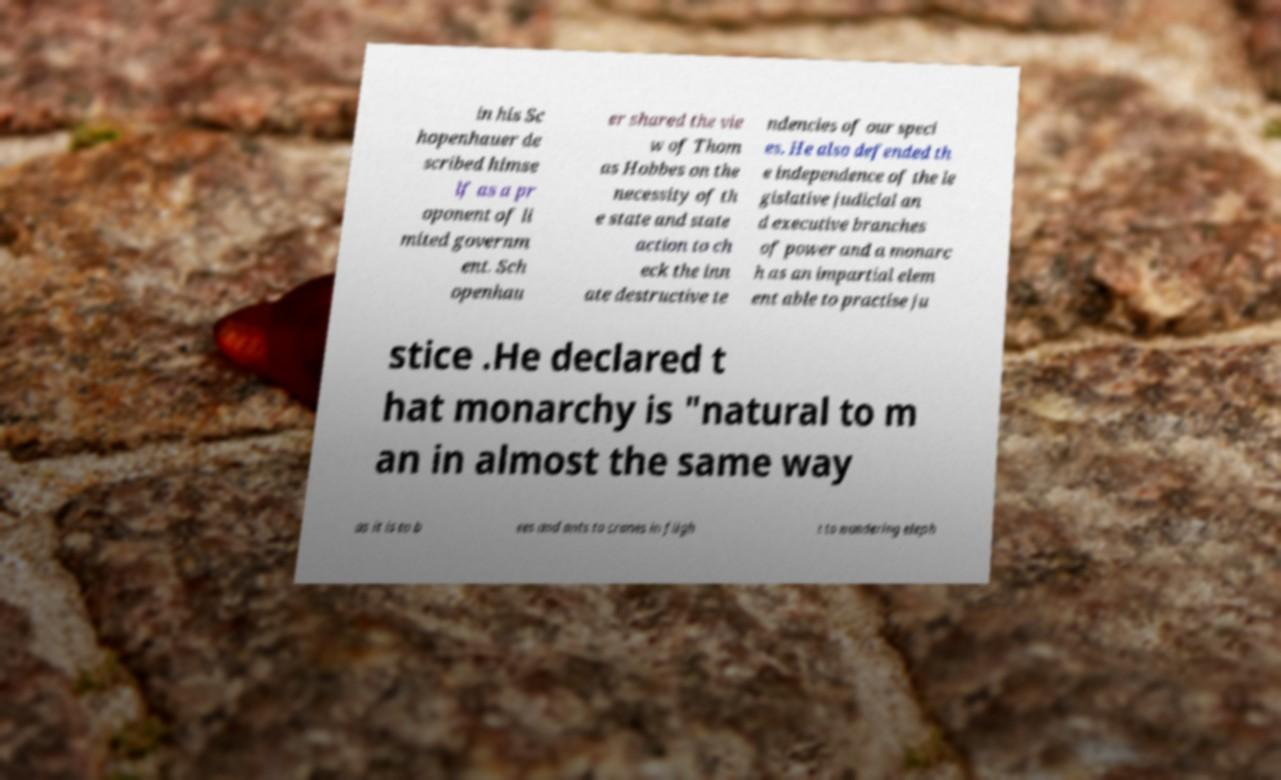Could you extract and type out the text from this image? in his Sc hopenhauer de scribed himse lf as a pr oponent of li mited governm ent. Sch openhau er shared the vie w of Thom as Hobbes on the necessity of th e state and state action to ch eck the inn ate destructive te ndencies of our speci es. He also defended th e independence of the le gislative judicial an d executive branches of power and a monarc h as an impartial elem ent able to practise ju stice .He declared t hat monarchy is "natural to m an in almost the same way as it is to b ees and ants to cranes in fligh t to wandering eleph 